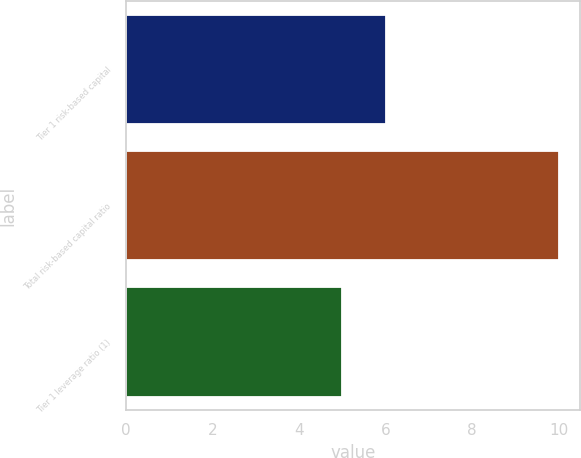<chart> <loc_0><loc_0><loc_500><loc_500><bar_chart><fcel>Tier 1 risk-based capital<fcel>Total risk-based capital ratio<fcel>Tier 1 leverage ratio (1)<nl><fcel>6<fcel>10<fcel>5<nl></chart> 